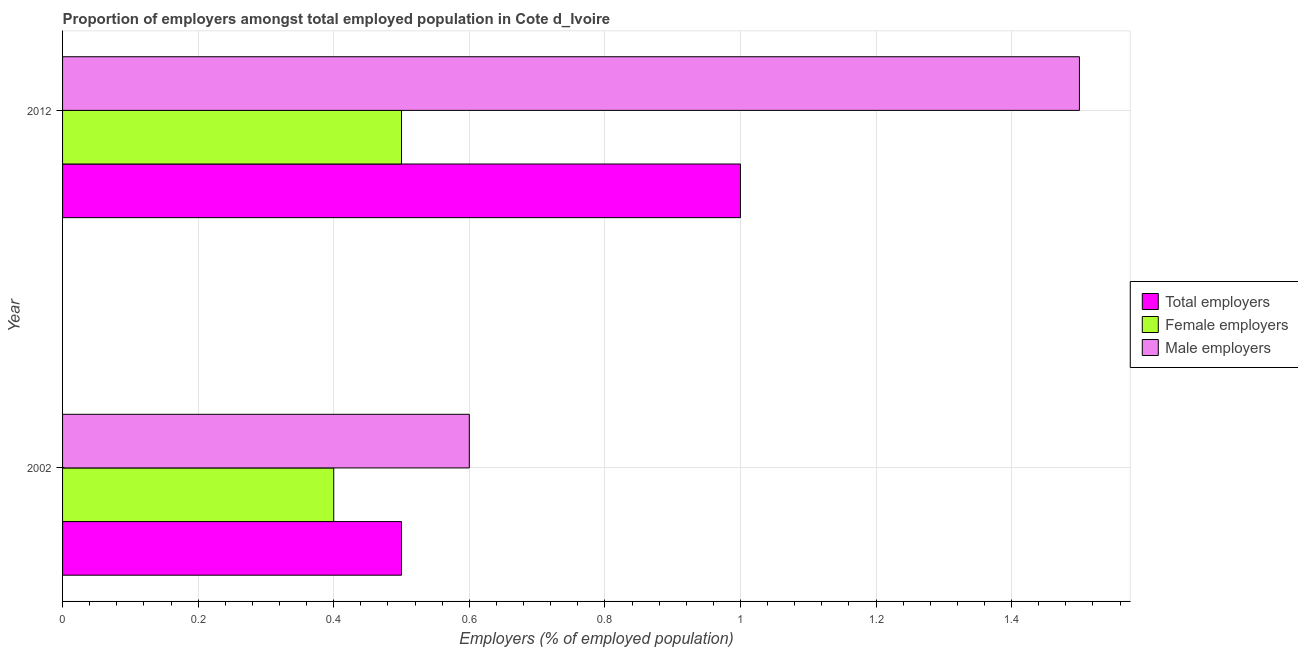How many bars are there on the 1st tick from the top?
Your answer should be compact. 3. What is the label of the 1st group of bars from the top?
Your answer should be very brief. 2012. What is the percentage of female employers in 2002?
Your answer should be compact. 0.4. Across all years, what is the maximum percentage of male employers?
Provide a short and direct response. 1.5. Across all years, what is the minimum percentage of male employers?
Your answer should be very brief. 0.6. In which year was the percentage of male employers maximum?
Keep it short and to the point. 2012. In which year was the percentage of female employers minimum?
Provide a succinct answer. 2002. What is the total percentage of female employers in the graph?
Provide a short and direct response. 0.9. What is the difference between the percentage of male employers in 2002 and that in 2012?
Provide a short and direct response. -0.9. What is the average percentage of female employers per year?
Give a very brief answer. 0.45. In how many years, is the percentage of male employers greater than 1.2800000000000002 %?
Ensure brevity in your answer.  1. Is the percentage of total employers in 2002 less than that in 2012?
Offer a terse response. Yes. In how many years, is the percentage of total employers greater than the average percentage of total employers taken over all years?
Provide a succinct answer. 1. What does the 3rd bar from the top in 2012 represents?
Provide a succinct answer. Total employers. What does the 2nd bar from the bottom in 2002 represents?
Provide a short and direct response. Female employers. Is it the case that in every year, the sum of the percentage of total employers and percentage of female employers is greater than the percentage of male employers?
Ensure brevity in your answer.  No. How many bars are there?
Offer a terse response. 6. Are all the bars in the graph horizontal?
Your answer should be compact. Yes. What is the difference between two consecutive major ticks on the X-axis?
Ensure brevity in your answer.  0.2. Where does the legend appear in the graph?
Provide a succinct answer. Center right. How are the legend labels stacked?
Your answer should be compact. Vertical. What is the title of the graph?
Ensure brevity in your answer.  Proportion of employers amongst total employed population in Cote d_Ivoire. Does "Ages 20-60" appear as one of the legend labels in the graph?
Offer a very short reply. No. What is the label or title of the X-axis?
Keep it short and to the point. Employers (% of employed population). What is the label or title of the Y-axis?
Your answer should be very brief. Year. What is the Employers (% of employed population) in Female employers in 2002?
Give a very brief answer. 0.4. What is the Employers (% of employed population) of Male employers in 2002?
Provide a short and direct response. 0.6. What is the Employers (% of employed population) of Total employers in 2012?
Give a very brief answer. 1. What is the Employers (% of employed population) of Female employers in 2012?
Offer a very short reply. 0.5. Across all years, what is the maximum Employers (% of employed population) of Female employers?
Make the answer very short. 0.5. Across all years, what is the maximum Employers (% of employed population) of Male employers?
Your answer should be compact. 1.5. Across all years, what is the minimum Employers (% of employed population) in Total employers?
Give a very brief answer. 0.5. Across all years, what is the minimum Employers (% of employed population) of Female employers?
Your answer should be very brief. 0.4. Across all years, what is the minimum Employers (% of employed population) of Male employers?
Your response must be concise. 0.6. What is the total Employers (% of employed population) in Male employers in the graph?
Your answer should be compact. 2.1. What is the difference between the Employers (% of employed population) in Total employers in 2002 and that in 2012?
Your answer should be compact. -0.5. What is the difference between the Employers (% of employed population) in Female employers in 2002 and that in 2012?
Your answer should be very brief. -0.1. What is the difference between the Employers (% of employed population) of Male employers in 2002 and that in 2012?
Provide a succinct answer. -0.9. What is the difference between the Employers (% of employed population) of Total employers in 2002 and the Employers (% of employed population) of Female employers in 2012?
Make the answer very short. 0. What is the difference between the Employers (% of employed population) in Female employers in 2002 and the Employers (% of employed population) in Male employers in 2012?
Provide a succinct answer. -1.1. What is the average Employers (% of employed population) in Female employers per year?
Offer a very short reply. 0.45. What is the average Employers (% of employed population) in Male employers per year?
Offer a very short reply. 1.05. In the year 2002, what is the difference between the Employers (% of employed population) in Female employers and Employers (% of employed population) in Male employers?
Make the answer very short. -0.2. In the year 2012, what is the difference between the Employers (% of employed population) in Total employers and Employers (% of employed population) in Female employers?
Ensure brevity in your answer.  0.5. In the year 2012, what is the difference between the Employers (% of employed population) in Total employers and Employers (% of employed population) in Male employers?
Your answer should be very brief. -0.5. What is the ratio of the Employers (% of employed population) in Total employers in 2002 to that in 2012?
Your answer should be very brief. 0.5. What is the ratio of the Employers (% of employed population) of Female employers in 2002 to that in 2012?
Keep it short and to the point. 0.8. What is the ratio of the Employers (% of employed population) of Male employers in 2002 to that in 2012?
Provide a short and direct response. 0.4. What is the difference between the highest and the second highest Employers (% of employed population) in Male employers?
Ensure brevity in your answer.  0.9. What is the difference between the highest and the lowest Employers (% of employed population) in Total employers?
Provide a succinct answer. 0.5. What is the difference between the highest and the lowest Employers (% of employed population) in Female employers?
Ensure brevity in your answer.  0.1. What is the difference between the highest and the lowest Employers (% of employed population) in Male employers?
Provide a short and direct response. 0.9. 